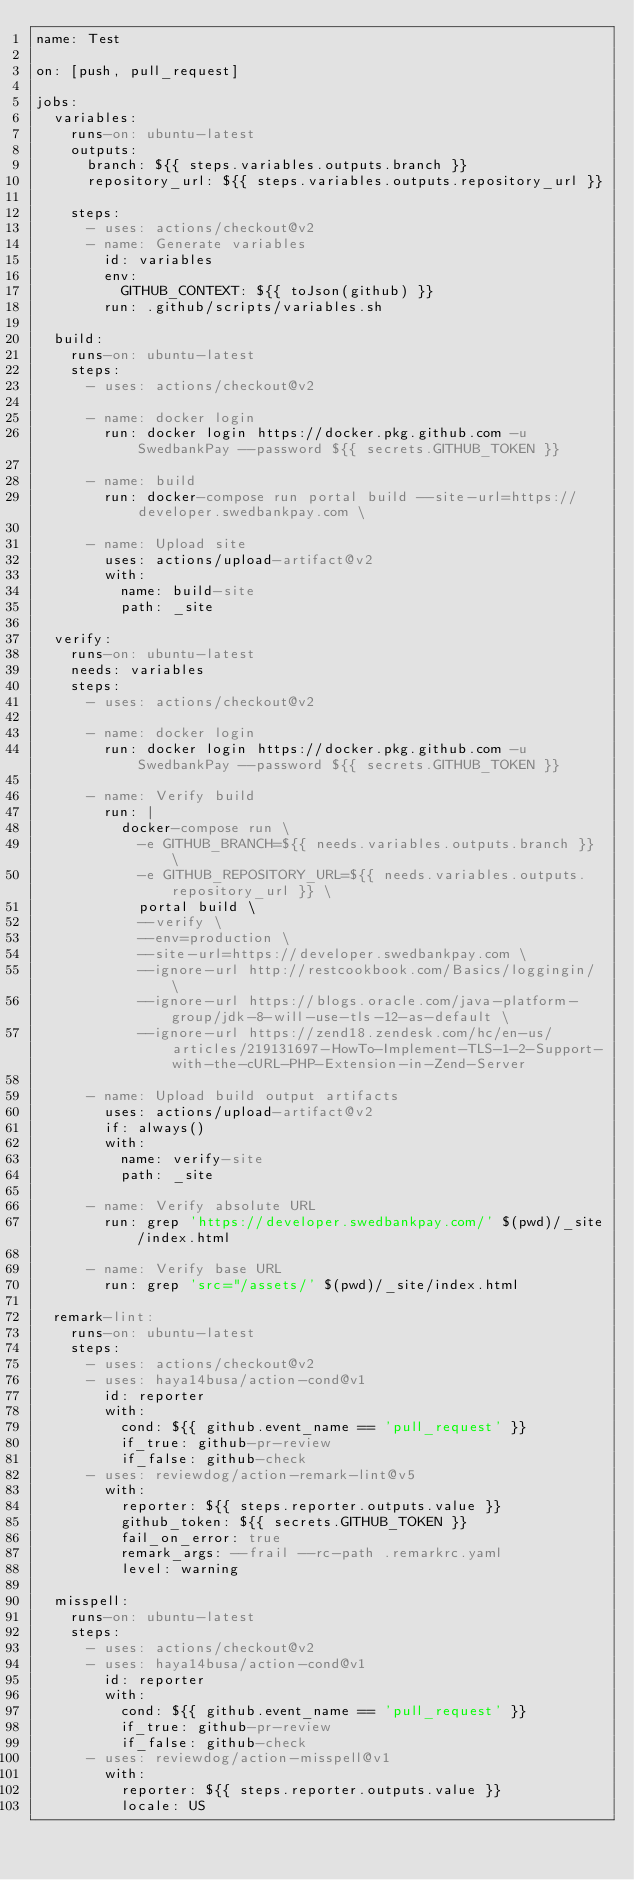<code> <loc_0><loc_0><loc_500><loc_500><_YAML_>name: Test

on: [push, pull_request]

jobs:
  variables:
    runs-on: ubuntu-latest
    outputs:
      branch: ${{ steps.variables.outputs.branch }}
      repository_url: ${{ steps.variables.outputs.repository_url }}

    steps:
      - uses: actions/checkout@v2
      - name: Generate variables
        id: variables
        env:
          GITHUB_CONTEXT: ${{ toJson(github) }}
        run: .github/scripts/variables.sh

  build:
    runs-on: ubuntu-latest
    steps:
      - uses: actions/checkout@v2

      - name: docker login
        run: docker login https://docker.pkg.github.com -u SwedbankPay --password ${{ secrets.GITHUB_TOKEN }}

      - name: build
        run: docker-compose run portal build --site-url=https://developer.swedbankpay.com \

      - name: Upload site
        uses: actions/upload-artifact@v2
        with:
          name: build-site
          path: _site

  verify:
    runs-on: ubuntu-latest
    needs: variables
    steps:
      - uses: actions/checkout@v2

      - name: docker login
        run: docker login https://docker.pkg.github.com -u SwedbankPay --password ${{ secrets.GITHUB_TOKEN }}

      - name: Verify build
        run: |
          docker-compose run \
            -e GITHUB_BRANCH=${{ needs.variables.outputs.branch }} \
            -e GITHUB_REPOSITORY_URL=${{ needs.variables.outputs.repository_url }} \
            portal build \
            --verify \
            --env=production \
            --site-url=https://developer.swedbankpay.com \
            --ignore-url http://restcookbook.com/Basics/loggingin/ \
            --ignore-url https://blogs.oracle.com/java-platform-group/jdk-8-will-use-tls-12-as-default \
            --ignore-url https://zend18.zendesk.com/hc/en-us/articles/219131697-HowTo-Implement-TLS-1-2-Support-with-the-cURL-PHP-Extension-in-Zend-Server

      - name: Upload build output artifacts
        uses: actions/upload-artifact@v2
        if: always()
        with:
          name: verify-site
          path: _site

      - name: Verify absolute URL
        run: grep 'https://developer.swedbankpay.com/' $(pwd)/_site/index.html

      - name: Verify base URL
        run: grep 'src="/assets/' $(pwd)/_site/index.html

  remark-lint:
    runs-on: ubuntu-latest
    steps:
      - uses: actions/checkout@v2
      - uses: haya14busa/action-cond@v1
        id: reporter
        with:
          cond: ${{ github.event_name == 'pull_request' }}
          if_true: github-pr-review
          if_false: github-check
      - uses: reviewdog/action-remark-lint@v5
        with:
          reporter: ${{ steps.reporter.outputs.value }}
          github_token: ${{ secrets.GITHUB_TOKEN }}
          fail_on_error: true
          remark_args: --frail --rc-path .remarkrc.yaml
          level: warning

  misspell:
    runs-on: ubuntu-latest
    steps:
      - uses: actions/checkout@v2
      - uses: haya14busa/action-cond@v1
        id: reporter
        with:
          cond: ${{ github.event_name == 'pull_request' }}
          if_true: github-pr-review
          if_false: github-check
      - uses: reviewdog/action-misspell@v1
        with:
          reporter: ${{ steps.reporter.outputs.value }}
          locale: US
</code> 